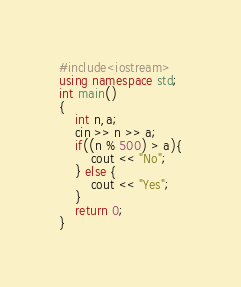Convert code to text. <code><loc_0><loc_0><loc_500><loc_500><_C++_>#include<iostream>
using namespace std;
int main()
{
    int n,a;
    cin >> n >> a;
    if((n % 500) > a){
        cout << "No";
    } else {
        cout << "Yes";
    }
    return 0;
}</code> 